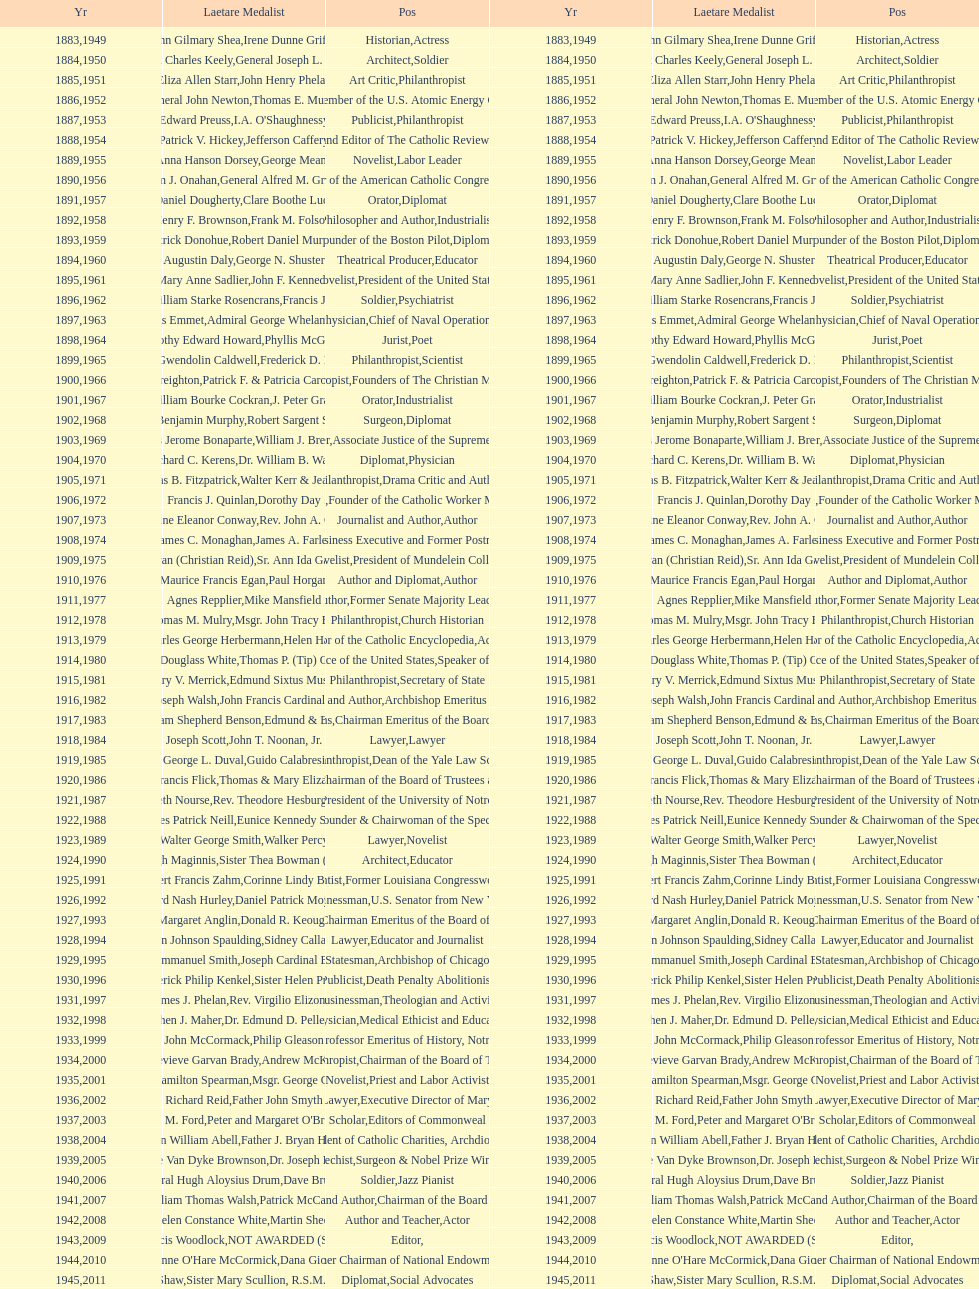Who has won this medal and the nobel prize as well? Dr. Joseph E. Murray. 